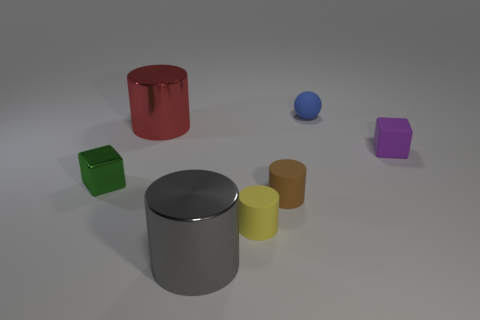Add 1 green metallic cylinders. How many objects exist? 8 Subtract all green cylinders. Subtract all green balls. How many cylinders are left? 4 Subtract all spheres. How many objects are left? 6 Subtract 0 purple cylinders. How many objects are left? 7 Subtract all small purple cylinders. Subtract all matte cylinders. How many objects are left? 5 Add 2 large gray metal cylinders. How many large gray metal cylinders are left? 3 Add 4 small green metallic things. How many small green metallic things exist? 5 